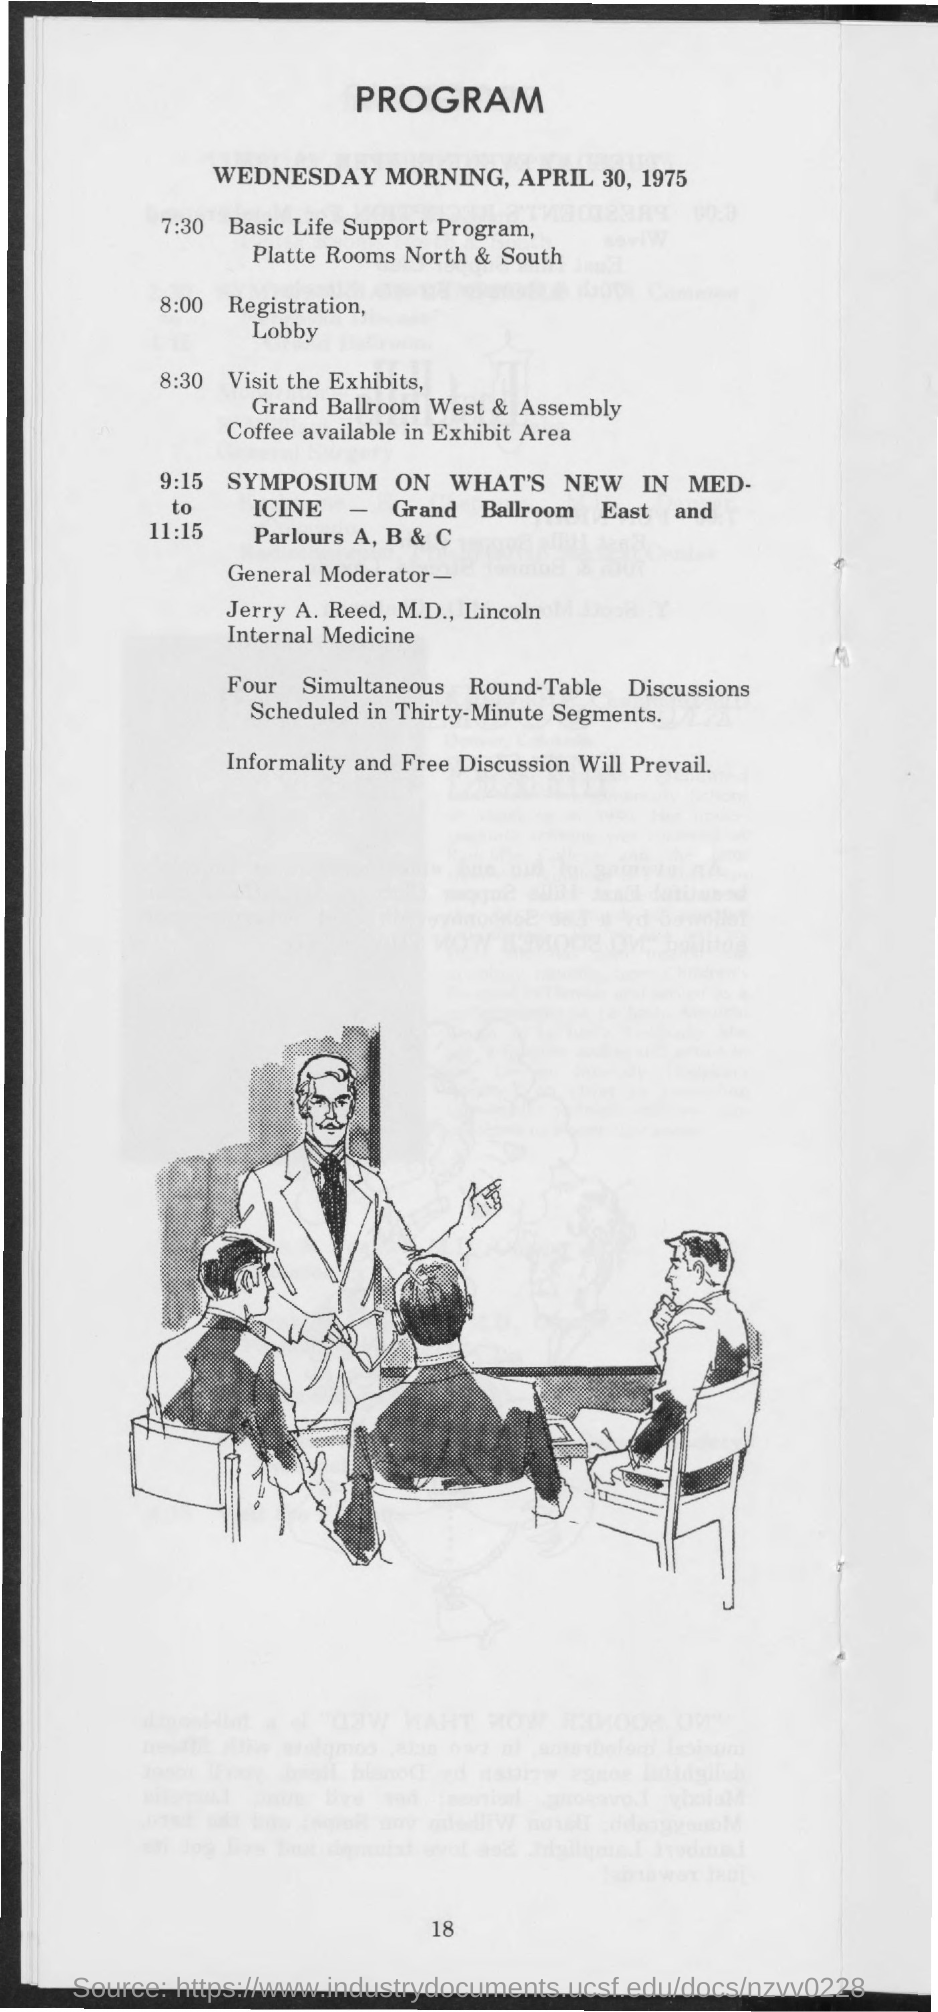Which date's program is this?
Give a very brief answer. April 30, 1975. What is scheduled at 7:30?
Offer a terse response. Basic life support program, platte rooms north & south. What is scheduled at 8:00?
Ensure brevity in your answer.  Registration. 